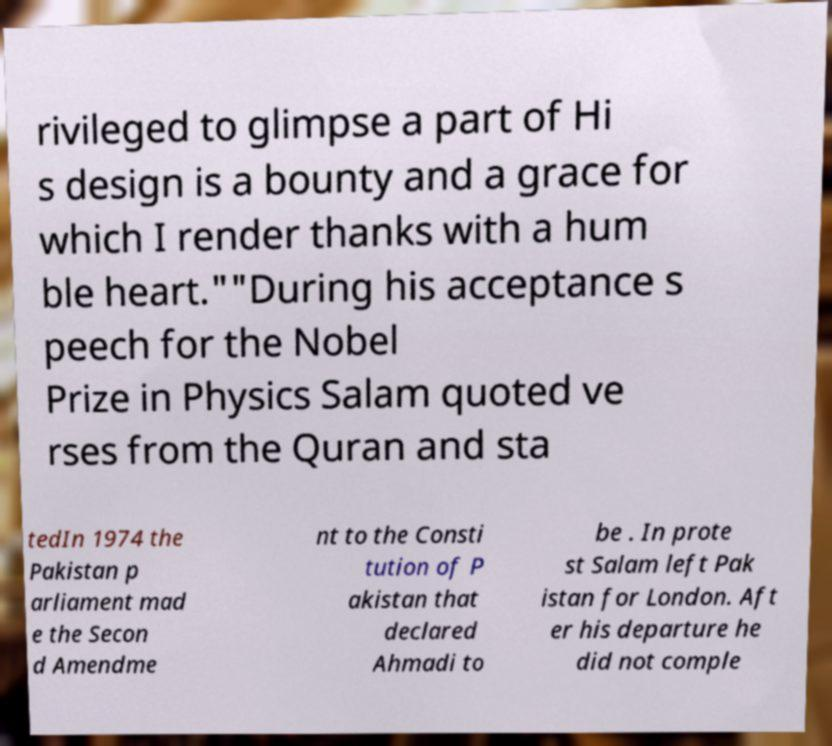What messages or text are displayed in this image? I need them in a readable, typed format. rivileged to glimpse a part of Hi s design is a bounty and a grace for which I render thanks with a hum ble heart.""During his acceptance s peech for the Nobel Prize in Physics Salam quoted ve rses from the Quran and sta tedIn 1974 the Pakistan p arliament mad e the Secon d Amendme nt to the Consti tution of P akistan that declared Ahmadi to be . In prote st Salam left Pak istan for London. Aft er his departure he did not comple 